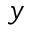Convert formula to latex. <formula><loc_0><loc_0><loc_500><loc_500>y</formula> 